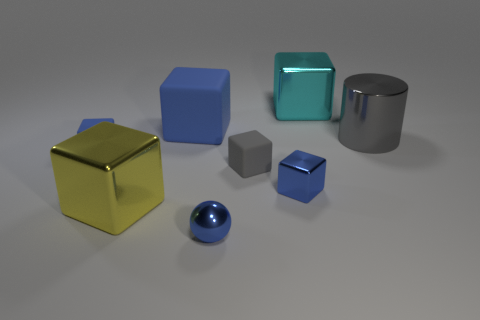The gray metallic cylinder is what size?
Offer a very short reply. Large. Is the number of blue shiny spheres that are on the left side of the yellow block less than the number of big green metallic cylinders?
Your response must be concise. No. Do the blue metallic cube and the cyan shiny cube have the same size?
Your answer should be compact. No. Is there anything else that is the same size as the yellow metal thing?
Make the answer very short. Yes. What color is the ball that is the same material as the cylinder?
Provide a short and direct response. Blue. Is the number of large blue matte blocks left of the blue sphere less than the number of tiny matte things that are on the right side of the large blue rubber thing?
Your answer should be compact. No. How many other large rubber cylinders are the same color as the cylinder?
Provide a short and direct response. 0. What is the material of the ball that is the same color as the big matte cube?
Offer a terse response. Metal. How many objects are behind the big yellow metallic cube and to the left of the large blue object?
Give a very brief answer. 1. What is the material of the small thing that is left of the large object in front of the big cylinder?
Keep it short and to the point. Rubber. 